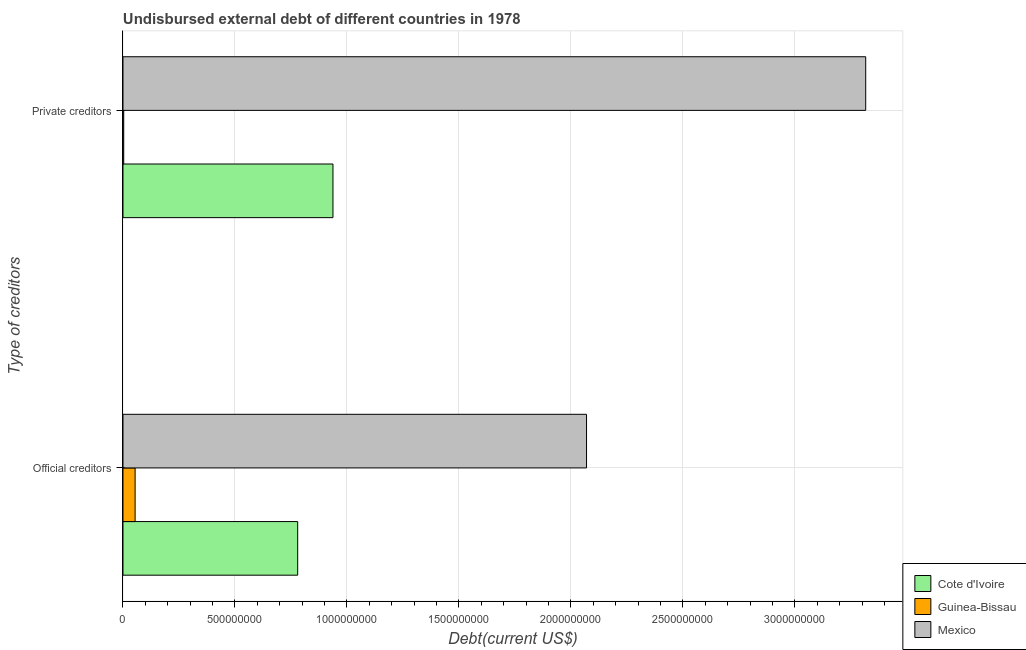How many different coloured bars are there?
Your response must be concise. 3. How many groups of bars are there?
Provide a succinct answer. 2. Are the number of bars per tick equal to the number of legend labels?
Your answer should be very brief. Yes. What is the label of the 2nd group of bars from the top?
Make the answer very short. Official creditors. What is the undisbursed external debt of official creditors in Cote d'Ivoire?
Offer a terse response. 7.80e+08. Across all countries, what is the maximum undisbursed external debt of private creditors?
Provide a succinct answer. 3.32e+09. Across all countries, what is the minimum undisbursed external debt of official creditors?
Offer a terse response. 5.41e+07. In which country was the undisbursed external debt of private creditors minimum?
Offer a very short reply. Guinea-Bissau. What is the total undisbursed external debt of private creditors in the graph?
Keep it short and to the point. 4.26e+09. What is the difference between the undisbursed external debt of official creditors in Cote d'Ivoire and that in Guinea-Bissau?
Your response must be concise. 7.26e+08. What is the difference between the undisbursed external debt of private creditors in Guinea-Bissau and the undisbursed external debt of official creditors in Cote d'Ivoire?
Keep it short and to the point. -7.77e+08. What is the average undisbursed external debt of private creditors per country?
Ensure brevity in your answer.  1.42e+09. What is the difference between the undisbursed external debt of official creditors and undisbursed external debt of private creditors in Cote d'Ivoire?
Make the answer very short. -1.58e+08. What is the ratio of the undisbursed external debt of official creditors in Guinea-Bissau to that in Cote d'Ivoire?
Make the answer very short. 0.07. In how many countries, is the undisbursed external debt of private creditors greater than the average undisbursed external debt of private creditors taken over all countries?
Keep it short and to the point. 1. What does the 2nd bar from the bottom in Private creditors represents?
Your response must be concise. Guinea-Bissau. How many bars are there?
Make the answer very short. 6. What is the difference between two consecutive major ticks on the X-axis?
Keep it short and to the point. 5.00e+08. Are the values on the major ticks of X-axis written in scientific E-notation?
Offer a terse response. No. Does the graph contain any zero values?
Your answer should be compact. No. Where does the legend appear in the graph?
Keep it short and to the point. Bottom right. What is the title of the graph?
Make the answer very short. Undisbursed external debt of different countries in 1978. What is the label or title of the X-axis?
Offer a terse response. Debt(current US$). What is the label or title of the Y-axis?
Your answer should be very brief. Type of creditors. What is the Debt(current US$) in Cote d'Ivoire in Official creditors?
Ensure brevity in your answer.  7.80e+08. What is the Debt(current US$) of Guinea-Bissau in Official creditors?
Offer a terse response. 5.41e+07. What is the Debt(current US$) in Mexico in Official creditors?
Ensure brevity in your answer.  2.07e+09. What is the Debt(current US$) in Cote d'Ivoire in Private creditors?
Offer a very short reply. 9.38e+08. What is the Debt(current US$) of Guinea-Bissau in Private creditors?
Offer a very short reply. 3.32e+06. What is the Debt(current US$) in Mexico in Private creditors?
Make the answer very short. 3.32e+09. Across all Type of creditors, what is the maximum Debt(current US$) in Cote d'Ivoire?
Give a very brief answer. 9.38e+08. Across all Type of creditors, what is the maximum Debt(current US$) of Guinea-Bissau?
Provide a short and direct response. 5.41e+07. Across all Type of creditors, what is the maximum Debt(current US$) of Mexico?
Offer a very short reply. 3.32e+09. Across all Type of creditors, what is the minimum Debt(current US$) in Cote d'Ivoire?
Make the answer very short. 7.80e+08. Across all Type of creditors, what is the minimum Debt(current US$) of Guinea-Bissau?
Make the answer very short. 3.32e+06. Across all Type of creditors, what is the minimum Debt(current US$) of Mexico?
Your answer should be very brief. 2.07e+09. What is the total Debt(current US$) in Cote d'Ivoire in the graph?
Make the answer very short. 1.72e+09. What is the total Debt(current US$) in Guinea-Bissau in the graph?
Provide a short and direct response. 5.74e+07. What is the total Debt(current US$) in Mexico in the graph?
Offer a very short reply. 5.39e+09. What is the difference between the Debt(current US$) in Cote d'Ivoire in Official creditors and that in Private creditors?
Provide a short and direct response. -1.58e+08. What is the difference between the Debt(current US$) of Guinea-Bissau in Official creditors and that in Private creditors?
Your answer should be very brief. 5.08e+07. What is the difference between the Debt(current US$) in Mexico in Official creditors and that in Private creditors?
Provide a succinct answer. -1.25e+09. What is the difference between the Debt(current US$) of Cote d'Ivoire in Official creditors and the Debt(current US$) of Guinea-Bissau in Private creditors?
Your answer should be very brief. 7.77e+08. What is the difference between the Debt(current US$) of Cote d'Ivoire in Official creditors and the Debt(current US$) of Mexico in Private creditors?
Make the answer very short. -2.54e+09. What is the difference between the Debt(current US$) in Guinea-Bissau in Official creditors and the Debt(current US$) in Mexico in Private creditors?
Ensure brevity in your answer.  -3.26e+09. What is the average Debt(current US$) in Cote d'Ivoire per Type of creditors?
Give a very brief answer. 8.59e+08. What is the average Debt(current US$) in Guinea-Bissau per Type of creditors?
Offer a very short reply. 2.87e+07. What is the average Debt(current US$) in Mexico per Type of creditors?
Keep it short and to the point. 2.69e+09. What is the difference between the Debt(current US$) of Cote d'Ivoire and Debt(current US$) of Guinea-Bissau in Official creditors?
Provide a succinct answer. 7.26e+08. What is the difference between the Debt(current US$) in Cote d'Ivoire and Debt(current US$) in Mexico in Official creditors?
Your response must be concise. -1.29e+09. What is the difference between the Debt(current US$) in Guinea-Bissau and Debt(current US$) in Mexico in Official creditors?
Provide a short and direct response. -2.02e+09. What is the difference between the Debt(current US$) in Cote d'Ivoire and Debt(current US$) in Guinea-Bissau in Private creditors?
Your answer should be very brief. 9.34e+08. What is the difference between the Debt(current US$) in Cote d'Ivoire and Debt(current US$) in Mexico in Private creditors?
Your answer should be compact. -2.38e+09. What is the difference between the Debt(current US$) of Guinea-Bissau and Debt(current US$) of Mexico in Private creditors?
Give a very brief answer. -3.31e+09. What is the ratio of the Debt(current US$) of Cote d'Ivoire in Official creditors to that in Private creditors?
Your answer should be compact. 0.83. What is the ratio of the Debt(current US$) in Guinea-Bissau in Official creditors to that in Private creditors?
Keep it short and to the point. 16.31. What is the ratio of the Debt(current US$) in Mexico in Official creditors to that in Private creditors?
Your answer should be very brief. 0.62. What is the difference between the highest and the second highest Debt(current US$) of Cote d'Ivoire?
Keep it short and to the point. 1.58e+08. What is the difference between the highest and the second highest Debt(current US$) of Guinea-Bissau?
Provide a succinct answer. 5.08e+07. What is the difference between the highest and the second highest Debt(current US$) of Mexico?
Ensure brevity in your answer.  1.25e+09. What is the difference between the highest and the lowest Debt(current US$) of Cote d'Ivoire?
Offer a very short reply. 1.58e+08. What is the difference between the highest and the lowest Debt(current US$) of Guinea-Bissau?
Give a very brief answer. 5.08e+07. What is the difference between the highest and the lowest Debt(current US$) of Mexico?
Your answer should be compact. 1.25e+09. 